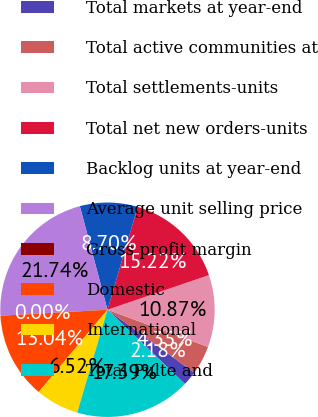<chart> <loc_0><loc_0><loc_500><loc_500><pie_chart><fcel>Total markets at year-end<fcel>Total active communities at<fcel>Total settlements-units<fcel>Total net new orders-units<fcel>Backlog units at year-end<fcel>Average unit selling price<fcel>Gross profit margin<fcel>Domestic<fcel>International<fcel>Total Pulte and<nl><fcel>2.18%<fcel>4.35%<fcel>10.87%<fcel>15.22%<fcel>8.7%<fcel>21.74%<fcel>0.0%<fcel>13.04%<fcel>6.52%<fcel>17.39%<nl></chart> 